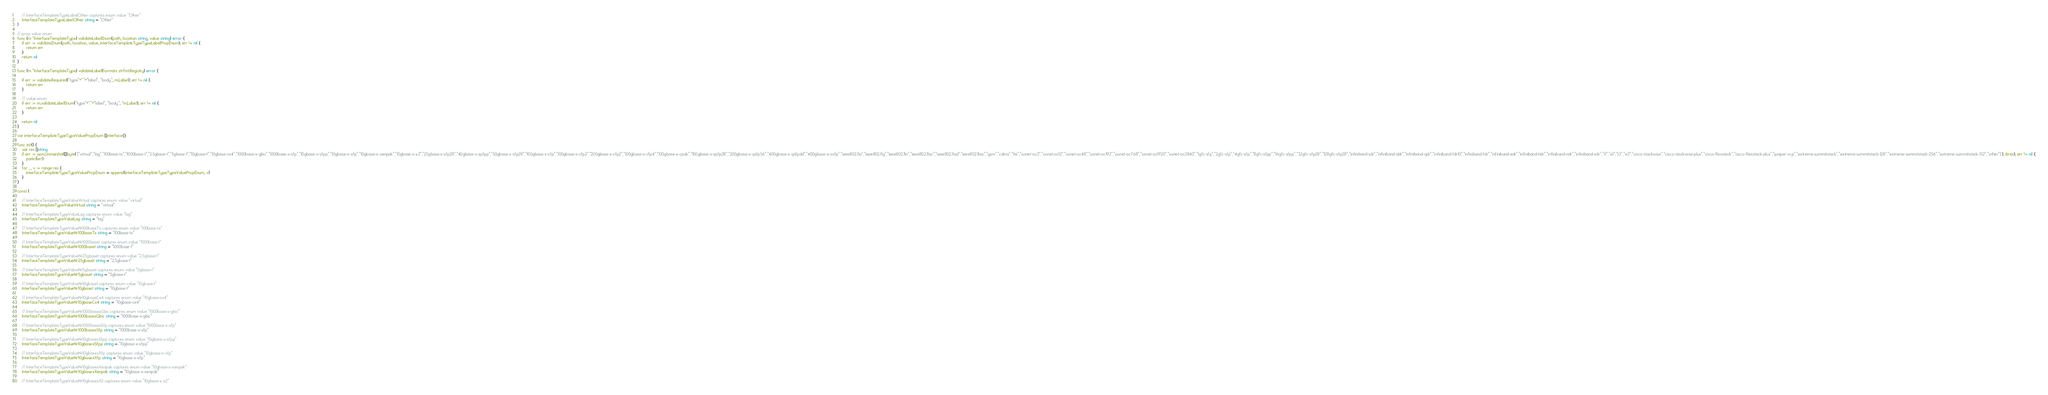<code> <loc_0><loc_0><loc_500><loc_500><_Go_>
	// InterfaceTemplateTypeLabelOther captures enum value "Other"
	InterfaceTemplateTypeLabelOther string = "Other"
)

// prop value enum
func (m *InterfaceTemplateType) validateLabelEnum(path, location string, value string) error {
	if err := validate.Enum(path, location, value, interfaceTemplateTypeTypeLabelPropEnum); err != nil {
		return err
	}
	return nil
}

func (m *InterfaceTemplateType) validateLabel(formats strfmt.Registry) error {

	if err := validate.Required("type"+"."+"label", "body", m.Label); err != nil {
		return err
	}

	// value enum
	if err := m.validateLabelEnum("type"+"."+"label", "body", *m.Label); err != nil {
		return err
	}

	return nil
}

var interfaceTemplateTypeTypeValuePropEnum []interface{}

func init() {
	var res []string
	if err := json.Unmarshal([]byte(`["virtual","lag","100base-tx","1000base-t","2.5gbase-t","5gbase-t","10gbase-t","10gbase-cx4","1000base-x-gbic","1000base-x-sfp","10gbase-x-sfpp","10gbase-x-xfp","10gbase-x-xenpak","10gbase-x-x2","25gbase-x-sfp28","40gbase-x-qsfpp","50gbase-x-sfp28","100gbase-x-cfp","100gbase-x-cfp2","200gbase-x-cfp2","100gbase-x-cfp4","100gbase-x-cpak","100gbase-x-qsfp28","200gbase-x-qsfp56","400gbase-x-qsfpdd","400gbase-x-osfp","ieee802.11a","ieee802.11g","ieee802.11n","ieee802.11ac","ieee802.11ad","ieee802.11ax","gsm","cdma","lte","sonet-oc3","sonet-oc12","sonet-oc48","sonet-oc192","sonet-oc768","sonet-oc1920","sonet-oc3840","1gfc-sfp","2gfc-sfp","4gfc-sfp","8gfc-sfpp","16gfc-sfpp","32gfc-sfp28","128gfc-sfp28","infiniband-sdr","infiniband-ddr","infiniband-qdr","infiniband-fdr10","infiniband-fdr","infiniband-edr","infiniband-hdr","infiniband-ndr","infiniband-xdr","t1","e1","t3","e3","cisco-stackwise","cisco-stackwise-plus","cisco-flexstack","cisco-flexstack-plus","juniper-vcp","extreme-summitstack","extreme-summitstack-128","extreme-summitstack-256","extreme-summitstack-512","other"]`), &res); err != nil {
		panic(err)
	}
	for _, v := range res {
		interfaceTemplateTypeTypeValuePropEnum = append(interfaceTemplateTypeTypeValuePropEnum, v)
	}
}

const (

	// InterfaceTemplateTypeValueVirtual captures enum value "virtual"
	InterfaceTemplateTypeValueVirtual string = "virtual"

	// InterfaceTemplateTypeValueLag captures enum value "lag"
	InterfaceTemplateTypeValueLag string = "lag"

	// InterfaceTemplateTypeValueNr100baseTx captures enum value "100base-tx"
	InterfaceTemplateTypeValueNr100baseTx string = "100base-tx"

	// InterfaceTemplateTypeValueNr1000baset captures enum value "1000base-t"
	InterfaceTemplateTypeValueNr1000baset string = "1000base-t"

	// InterfaceTemplateTypeValueNr25gbaset captures enum value "2.5gbase-t"
	InterfaceTemplateTypeValueNr25gbaset string = "2.5gbase-t"

	// InterfaceTemplateTypeValueNr5gbaset captures enum value "5gbase-t"
	InterfaceTemplateTypeValueNr5gbaset string = "5gbase-t"

	// InterfaceTemplateTypeValueNr10gbaset captures enum value "10gbase-t"
	InterfaceTemplateTypeValueNr10gbaset string = "10gbase-t"

	// InterfaceTemplateTypeValueNr10gbaseCx4 captures enum value "10gbase-cx4"
	InterfaceTemplateTypeValueNr10gbaseCx4 string = "10gbase-cx4"

	// InterfaceTemplateTypeValueNr1000basexGbic captures enum value "1000base-x-gbic"
	InterfaceTemplateTypeValueNr1000basexGbic string = "1000base-x-gbic"

	// InterfaceTemplateTypeValueNr1000basexSfp captures enum value "1000base-x-sfp"
	InterfaceTemplateTypeValueNr1000basexSfp string = "1000base-x-sfp"

	// InterfaceTemplateTypeValueNr10gbasexSfpp captures enum value "10gbase-x-sfpp"
	InterfaceTemplateTypeValueNr10gbasexSfpp string = "10gbase-x-sfpp"

	// InterfaceTemplateTypeValueNr10gbasexXfp captures enum value "10gbase-x-xfp"
	InterfaceTemplateTypeValueNr10gbasexXfp string = "10gbase-x-xfp"

	// InterfaceTemplateTypeValueNr10gbasexXenpak captures enum value "10gbase-x-xenpak"
	InterfaceTemplateTypeValueNr10gbasexXenpak string = "10gbase-x-xenpak"

	// InterfaceTemplateTypeValueNr10gbasexX2 captures enum value "10gbase-x-x2"</code> 